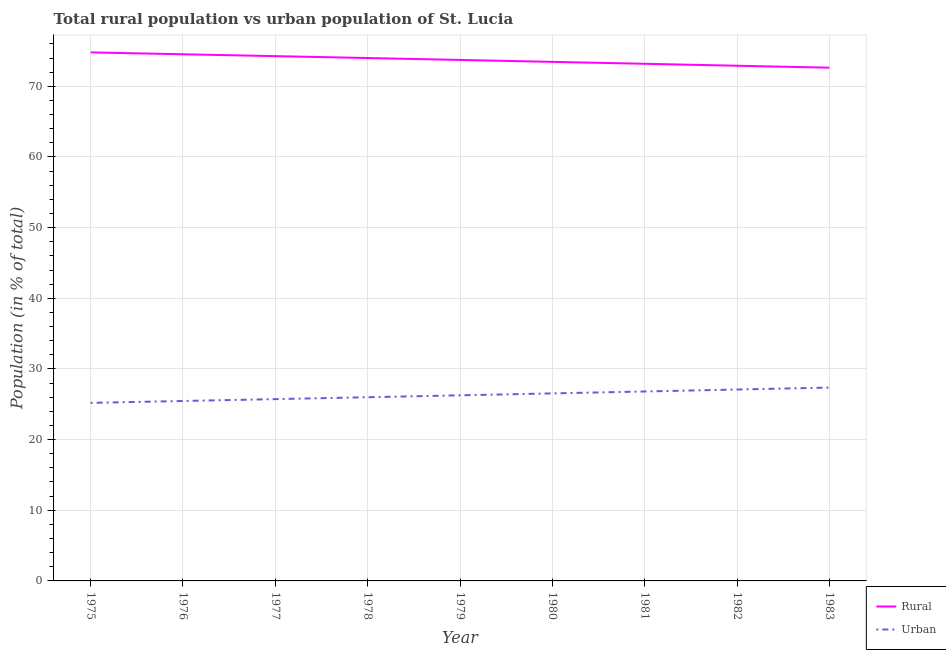What is the urban population in 1983?
Keep it short and to the point. 27.36. Across all years, what is the maximum rural population?
Your answer should be compact. 74.8. Across all years, what is the minimum rural population?
Offer a terse response. 72.64. In which year was the rural population maximum?
Your response must be concise. 1975. In which year was the urban population minimum?
Your answer should be compact. 1975. What is the total urban population in the graph?
Your answer should be very brief. 236.46. What is the difference between the urban population in 1978 and that in 1980?
Your answer should be very brief. -0.54. What is the difference between the rural population in 1980 and the urban population in 1981?
Provide a short and direct response. 46.65. What is the average urban population per year?
Keep it short and to the point. 26.27. In the year 1982, what is the difference between the urban population and rural population?
Make the answer very short. -45.83. What is the ratio of the urban population in 1980 to that in 1983?
Your answer should be very brief. 0.97. Is the urban population in 1978 less than that in 1981?
Give a very brief answer. Yes. What is the difference between the highest and the second highest rural population?
Keep it short and to the point. 0.27. What is the difference between the highest and the lowest rural population?
Ensure brevity in your answer.  2.16. In how many years, is the urban population greater than the average urban population taken over all years?
Provide a succinct answer. 4. Is the sum of the rural population in 1975 and 1980 greater than the maximum urban population across all years?
Provide a short and direct response. Yes. Is the urban population strictly less than the rural population over the years?
Provide a succinct answer. Yes. Are the values on the major ticks of Y-axis written in scientific E-notation?
Your answer should be compact. No. Does the graph contain any zero values?
Provide a short and direct response. No. What is the title of the graph?
Offer a very short reply. Total rural population vs urban population of St. Lucia. What is the label or title of the X-axis?
Provide a short and direct response. Year. What is the label or title of the Y-axis?
Give a very brief answer. Population (in % of total). What is the Population (in % of total) in Rural in 1975?
Keep it short and to the point. 74.8. What is the Population (in % of total) in Urban in 1975?
Make the answer very short. 25.2. What is the Population (in % of total) of Rural in 1976?
Offer a terse response. 74.53. What is the Population (in % of total) of Urban in 1976?
Give a very brief answer. 25.46. What is the Population (in % of total) of Rural in 1977?
Your answer should be very brief. 74.27. What is the Population (in % of total) in Urban in 1977?
Your answer should be very brief. 25.73. What is the Population (in % of total) of Rural in 1978?
Keep it short and to the point. 74. What is the Population (in % of total) in Urban in 1978?
Your answer should be compact. 26. What is the Population (in % of total) of Rural in 1979?
Keep it short and to the point. 73.73. What is the Population (in % of total) in Urban in 1979?
Offer a terse response. 26.27. What is the Population (in % of total) of Rural in 1980?
Offer a very short reply. 73.46. What is the Population (in % of total) in Urban in 1980?
Offer a terse response. 26.54. What is the Population (in % of total) of Rural in 1981?
Offer a terse response. 73.19. What is the Population (in % of total) of Urban in 1981?
Ensure brevity in your answer.  26.81. What is the Population (in % of total) in Rural in 1982?
Provide a succinct answer. 72.91. What is the Population (in % of total) of Urban in 1982?
Provide a short and direct response. 27.09. What is the Population (in % of total) of Rural in 1983?
Make the answer very short. 72.64. What is the Population (in % of total) in Urban in 1983?
Offer a very short reply. 27.36. Across all years, what is the maximum Population (in % of total) of Rural?
Make the answer very short. 74.8. Across all years, what is the maximum Population (in % of total) of Urban?
Make the answer very short. 27.36. Across all years, what is the minimum Population (in % of total) in Rural?
Your answer should be compact. 72.64. Across all years, what is the minimum Population (in % of total) in Urban?
Offer a terse response. 25.2. What is the total Population (in % of total) in Rural in the graph?
Make the answer very short. 663.54. What is the total Population (in % of total) of Urban in the graph?
Your answer should be very brief. 236.46. What is the difference between the Population (in % of total) of Rural in 1975 and that in 1976?
Keep it short and to the point. 0.27. What is the difference between the Population (in % of total) of Urban in 1975 and that in 1976?
Provide a short and direct response. -0.27. What is the difference between the Population (in % of total) in Rural in 1975 and that in 1977?
Make the answer very short. 0.53. What is the difference between the Population (in % of total) in Urban in 1975 and that in 1977?
Ensure brevity in your answer.  -0.53. What is the difference between the Population (in % of total) in Rural in 1975 and that in 1978?
Your response must be concise. 0.8. What is the difference between the Population (in % of total) of Urban in 1975 and that in 1978?
Keep it short and to the point. -0.8. What is the difference between the Population (in % of total) of Rural in 1975 and that in 1979?
Your answer should be very brief. 1.07. What is the difference between the Population (in % of total) in Urban in 1975 and that in 1979?
Keep it short and to the point. -1.07. What is the difference between the Population (in % of total) of Rural in 1975 and that in 1980?
Provide a succinct answer. 1.34. What is the difference between the Population (in % of total) of Urban in 1975 and that in 1980?
Ensure brevity in your answer.  -1.34. What is the difference between the Population (in % of total) of Rural in 1975 and that in 1981?
Offer a very short reply. 1.61. What is the difference between the Population (in % of total) in Urban in 1975 and that in 1981?
Keep it short and to the point. -1.61. What is the difference between the Population (in % of total) of Rural in 1975 and that in 1982?
Offer a terse response. 1.89. What is the difference between the Population (in % of total) of Urban in 1975 and that in 1982?
Offer a terse response. -1.89. What is the difference between the Population (in % of total) in Rural in 1975 and that in 1983?
Offer a very short reply. 2.16. What is the difference between the Population (in % of total) in Urban in 1975 and that in 1983?
Provide a short and direct response. -2.16. What is the difference between the Population (in % of total) in Rural in 1976 and that in 1977?
Ensure brevity in your answer.  0.27. What is the difference between the Population (in % of total) of Urban in 1976 and that in 1977?
Make the answer very short. -0.27. What is the difference between the Population (in % of total) of Rural in 1976 and that in 1978?
Your answer should be compact. 0.53. What is the difference between the Population (in % of total) in Urban in 1976 and that in 1978?
Your answer should be very brief. -0.53. What is the difference between the Population (in % of total) of Rural in 1976 and that in 1979?
Give a very brief answer. 0.8. What is the difference between the Population (in % of total) of Urban in 1976 and that in 1979?
Ensure brevity in your answer.  -0.8. What is the difference between the Population (in % of total) in Rural in 1976 and that in 1980?
Offer a terse response. 1.07. What is the difference between the Population (in % of total) of Urban in 1976 and that in 1980?
Provide a succinct answer. -1.07. What is the difference between the Population (in % of total) in Rural in 1976 and that in 1981?
Ensure brevity in your answer.  1.35. What is the difference between the Population (in % of total) of Urban in 1976 and that in 1981?
Provide a succinct answer. -1.35. What is the difference between the Population (in % of total) in Rural in 1976 and that in 1982?
Offer a terse response. 1.62. What is the difference between the Population (in % of total) in Urban in 1976 and that in 1982?
Your response must be concise. -1.62. What is the difference between the Population (in % of total) in Rural in 1976 and that in 1983?
Provide a short and direct response. 1.9. What is the difference between the Population (in % of total) of Urban in 1976 and that in 1983?
Keep it short and to the point. -1.9. What is the difference between the Population (in % of total) in Rural in 1977 and that in 1978?
Make the answer very short. 0.27. What is the difference between the Population (in % of total) of Urban in 1977 and that in 1978?
Keep it short and to the point. -0.27. What is the difference between the Population (in % of total) of Rural in 1977 and that in 1979?
Ensure brevity in your answer.  0.54. What is the difference between the Population (in % of total) of Urban in 1977 and that in 1979?
Provide a short and direct response. -0.54. What is the difference between the Population (in % of total) in Rural in 1977 and that in 1980?
Your answer should be very brief. 0.81. What is the difference between the Population (in % of total) in Urban in 1977 and that in 1980?
Your response must be concise. -0.81. What is the difference between the Population (in % of total) of Rural in 1977 and that in 1981?
Your answer should be compact. 1.08. What is the difference between the Population (in % of total) in Urban in 1977 and that in 1981?
Offer a terse response. -1.08. What is the difference between the Population (in % of total) of Rural in 1977 and that in 1982?
Offer a terse response. 1.36. What is the difference between the Population (in % of total) of Urban in 1977 and that in 1982?
Provide a succinct answer. -1.36. What is the difference between the Population (in % of total) in Rural in 1977 and that in 1983?
Your answer should be compact. 1.63. What is the difference between the Population (in % of total) in Urban in 1977 and that in 1983?
Your response must be concise. -1.63. What is the difference between the Population (in % of total) of Rural in 1978 and that in 1979?
Provide a short and direct response. 0.27. What is the difference between the Population (in % of total) in Urban in 1978 and that in 1979?
Provide a succinct answer. -0.27. What is the difference between the Population (in % of total) of Rural in 1978 and that in 1980?
Keep it short and to the point. 0.54. What is the difference between the Population (in % of total) of Urban in 1978 and that in 1980?
Your answer should be compact. -0.54. What is the difference between the Population (in % of total) of Rural in 1978 and that in 1981?
Offer a terse response. 0.81. What is the difference between the Population (in % of total) of Urban in 1978 and that in 1981?
Your response must be concise. -0.81. What is the difference between the Population (in % of total) of Rural in 1978 and that in 1982?
Ensure brevity in your answer.  1.09. What is the difference between the Population (in % of total) in Urban in 1978 and that in 1982?
Provide a short and direct response. -1.09. What is the difference between the Population (in % of total) of Rural in 1978 and that in 1983?
Your answer should be compact. 1.37. What is the difference between the Population (in % of total) in Urban in 1978 and that in 1983?
Your response must be concise. -1.37. What is the difference between the Population (in % of total) in Rural in 1979 and that in 1980?
Offer a very short reply. 0.27. What is the difference between the Population (in % of total) in Urban in 1979 and that in 1980?
Give a very brief answer. -0.27. What is the difference between the Population (in % of total) in Rural in 1979 and that in 1981?
Your answer should be very brief. 0.54. What is the difference between the Population (in % of total) of Urban in 1979 and that in 1981?
Your response must be concise. -0.54. What is the difference between the Population (in % of total) of Rural in 1979 and that in 1982?
Offer a terse response. 0.82. What is the difference between the Population (in % of total) of Urban in 1979 and that in 1982?
Your response must be concise. -0.82. What is the difference between the Population (in % of total) of Rural in 1979 and that in 1983?
Your response must be concise. 1.1. What is the difference between the Population (in % of total) of Urban in 1979 and that in 1983?
Give a very brief answer. -1.1. What is the difference between the Population (in % of total) of Rural in 1980 and that in 1981?
Give a very brief answer. 0.27. What is the difference between the Population (in % of total) of Urban in 1980 and that in 1981?
Give a very brief answer. -0.27. What is the difference between the Population (in % of total) in Rural in 1980 and that in 1982?
Your answer should be very brief. 0.55. What is the difference between the Population (in % of total) in Urban in 1980 and that in 1982?
Your answer should be compact. -0.55. What is the difference between the Population (in % of total) of Rural in 1980 and that in 1983?
Offer a very short reply. 0.82. What is the difference between the Population (in % of total) in Urban in 1980 and that in 1983?
Keep it short and to the point. -0.82. What is the difference between the Population (in % of total) of Rural in 1981 and that in 1982?
Provide a short and direct response. 0.28. What is the difference between the Population (in % of total) of Urban in 1981 and that in 1982?
Your answer should be compact. -0.28. What is the difference between the Population (in % of total) of Rural in 1981 and that in 1983?
Offer a terse response. 0.55. What is the difference between the Population (in % of total) in Urban in 1981 and that in 1983?
Offer a very short reply. -0.55. What is the difference between the Population (in % of total) of Rural in 1982 and that in 1983?
Your answer should be compact. 0.28. What is the difference between the Population (in % of total) in Urban in 1982 and that in 1983?
Your answer should be compact. -0.28. What is the difference between the Population (in % of total) of Rural in 1975 and the Population (in % of total) of Urban in 1976?
Give a very brief answer. 49.34. What is the difference between the Population (in % of total) in Rural in 1975 and the Population (in % of total) in Urban in 1977?
Offer a very short reply. 49.07. What is the difference between the Population (in % of total) of Rural in 1975 and the Population (in % of total) of Urban in 1978?
Offer a terse response. 48.8. What is the difference between the Population (in % of total) in Rural in 1975 and the Population (in % of total) in Urban in 1979?
Keep it short and to the point. 48.53. What is the difference between the Population (in % of total) of Rural in 1975 and the Population (in % of total) of Urban in 1980?
Provide a succinct answer. 48.26. What is the difference between the Population (in % of total) in Rural in 1975 and the Population (in % of total) in Urban in 1981?
Offer a terse response. 47.99. What is the difference between the Population (in % of total) in Rural in 1975 and the Population (in % of total) in Urban in 1982?
Provide a short and direct response. 47.71. What is the difference between the Population (in % of total) in Rural in 1975 and the Population (in % of total) in Urban in 1983?
Your answer should be very brief. 47.44. What is the difference between the Population (in % of total) of Rural in 1976 and the Population (in % of total) of Urban in 1977?
Provide a short and direct response. 48.8. What is the difference between the Population (in % of total) of Rural in 1976 and the Population (in % of total) of Urban in 1978?
Your answer should be compact. 48.54. What is the difference between the Population (in % of total) in Rural in 1976 and the Population (in % of total) in Urban in 1979?
Provide a short and direct response. 48.27. What is the difference between the Population (in % of total) of Rural in 1976 and the Population (in % of total) of Urban in 1980?
Your answer should be compact. 47.99. What is the difference between the Population (in % of total) in Rural in 1976 and the Population (in % of total) in Urban in 1981?
Offer a very short reply. 47.72. What is the difference between the Population (in % of total) of Rural in 1976 and the Population (in % of total) of Urban in 1982?
Keep it short and to the point. 47.45. What is the difference between the Population (in % of total) of Rural in 1976 and the Population (in % of total) of Urban in 1983?
Ensure brevity in your answer.  47.17. What is the difference between the Population (in % of total) of Rural in 1977 and the Population (in % of total) of Urban in 1978?
Give a very brief answer. 48.27. What is the difference between the Population (in % of total) of Rural in 1977 and the Population (in % of total) of Urban in 1979?
Your answer should be very brief. 48. What is the difference between the Population (in % of total) of Rural in 1977 and the Population (in % of total) of Urban in 1980?
Ensure brevity in your answer.  47.73. What is the difference between the Population (in % of total) in Rural in 1977 and the Population (in % of total) in Urban in 1981?
Keep it short and to the point. 47.46. What is the difference between the Population (in % of total) in Rural in 1977 and the Population (in % of total) in Urban in 1982?
Make the answer very short. 47.18. What is the difference between the Population (in % of total) in Rural in 1977 and the Population (in % of total) in Urban in 1983?
Give a very brief answer. 46.91. What is the difference between the Population (in % of total) in Rural in 1978 and the Population (in % of total) in Urban in 1979?
Your response must be concise. 47.73. What is the difference between the Population (in % of total) of Rural in 1978 and the Population (in % of total) of Urban in 1980?
Your answer should be compact. 47.46. What is the difference between the Population (in % of total) of Rural in 1978 and the Population (in % of total) of Urban in 1981?
Make the answer very short. 47.19. What is the difference between the Population (in % of total) in Rural in 1978 and the Population (in % of total) in Urban in 1982?
Provide a succinct answer. 46.91. What is the difference between the Population (in % of total) of Rural in 1978 and the Population (in % of total) of Urban in 1983?
Keep it short and to the point. 46.64. What is the difference between the Population (in % of total) of Rural in 1979 and the Population (in % of total) of Urban in 1980?
Make the answer very short. 47.19. What is the difference between the Population (in % of total) in Rural in 1979 and the Population (in % of total) in Urban in 1981?
Offer a terse response. 46.92. What is the difference between the Population (in % of total) in Rural in 1979 and the Population (in % of total) in Urban in 1982?
Ensure brevity in your answer.  46.65. What is the difference between the Population (in % of total) in Rural in 1979 and the Population (in % of total) in Urban in 1983?
Make the answer very short. 46.37. What is the difference between the Population (in % of total) of Rural in 1980 and the Population (in % of total) of Urban in 1981?
Give a very brief answer. 46.65. What is the difference between the Population (in % of total) in Rural in 1980 and the Population (in % of total) in Urban in 1982?
Ensure brevity in your answer.  46.37. What is the difference between the Population (in % of total) of Rural in 1980 and the Population (in % of total) of Urban in 1983?
Offer a very short reply. 46.1. What is the difference between the Population (in % of total) of Rural in 1981 and the Population (in % of total) of Urban in 1982?
Provide a short and direct response. 46.1. What is the difference between the Population (in % of total) in Rural in 1981 and the Population (in % of total) in Urban in 1983?
Offer a terse response. 45.82. What is the difference between the Population (in % of total) in Rural in 1982 and the Population (in % of total) in Urban in 1983?
Your answer should be very brief. 45.55. What is the average Population (in % of total) in Rural per year?
Your answer should be very brief. 73.73. What is the average Population (in % of total) in Urban per year?
Make the answer very short. 26.27. In the year 1975, what is the difference between the Population (in % of total) of Rural and Population (in % of total) of Urban?
Ensure brevity in your answer.  49.6. In the year 1976, what is the difference between the Population (in % of total) in Rural and Population (in % of total) in Urban?
Make the answer very short. 49.07. In the year 1977, what is the difference between the Population (in % of total) in Rural and Population (in % of total) in Urban?
Provide a succinct answer. 48.54. In the year 1978, what is the difference between the Population (in % of total) of Rural and Population (in % of total) of Urban?
Give a very brief answer. 48. In the year 1979, what is the difference between the Population (in % of total) in Rural and Population (in % of total) in Urban?
Your answer should be very brief. 47.46. In the year 1980, what is the difference between the Population (in % of total) in Rural and Population (in % of total) in Urban?
Your answer should be compact. 46.92. In the year 1981, what is the difference between the Population (in % of total) of Rural and Population (in % of total) of Urban?
Your answer should be compact. 46.38. In the year 1982, what is the difference between the Population (in % of total) in Rural and Population (in % of total) in Urban?
Provide a succinct answer. 45.83. In the year 1983, what is the difference between the Population (in % of total) of Rural and Population (in % of total) of Urban?
Your response must be concise. 45.27. What is the ratio of the Population (in % of total) of Urban in 1975 to that in 1976?
Give a very brief answer. 0.99. What is the ratio of the Population (in % of total) of Rural in 1975 to that in 1977?
Give a very brief answer. 1.01. What is the ratio of the Population (in % of total) in Urban in 1975 to that in 1977?
Keep it short and to the point. 0.98. What is the ratio of the Population (in % of total) in Rural in 1975 to that in 1978?
Make the answer very short. 1.01. What is the ratio of the Population (in % of total) of Urban in 1975 to that in 1978?
Keep it short and to the point. 0.97. What is the ratio of the Population (in % of total) of Rural in 1975 to that in 1979?
Make the answer very short. 1.01. What is the ratio of the Population (in % of total) of Urban in 1975 to that in 1979?
Give a very brief answer. 0.96. What is the ratio of the Population (in % of total) of Rural in 1975 to that in 1980?
Keep it short and to the point. 1.02. What is the ratio of the Population (in % of total) in Urban in 1975 to that in 1980?
Give a very brief answer. 0.95. What is the ratio of the Population (in % of total) in Rural in 1975 to that in 1981?
Keep it short and to the point. 1.02. What is the ratio of the Population (in % of total) of Urban in 1975 to that in 1981?
Make the answer very short. 0.94. What is the ratio of the Population (in % of total) of Rural in 1975 to that in 1982?
Offer a very short reply. 1.03. What is the ratio of the Population (in % of total) in Urban in 1975 to that in 1982?
Keep it short and to the point. 0.93. What is the ratio of the Population (in % of total) of Rural in 1975 to that in 1983?
Your response must be concise. 1.03. What is the ratio of the Population (in % of total) in Urban in 1975 to that in 1983?
Give a very brief answer. 0.92. What is the ratio of the Population (in % of total) in Rural in 1976 to that in 1978?
Provide a succinct answer. 1.01. What is the ratio of the Population (in % of total) in Urban in 1976 to that in 1978?
Your response must be concise. 0.98. What is the ratio of the Population (in % of total) in Rural in 1976 to that in 1979?
Give a very brief answer. 1.01. What is the ratio of the Population (in % of total) in Urban in 1976 to that in 1979?
Your response must be concise. 0.97. What is the ratio of the Population (in % of total) of Rural in 1976 to that in 1980?
Your response must be concise. 1.01. What is the ratio of the Population (in % of total) in Urban in 1976 to that in 1980?
Give a very brief answer. 0.96. What is the ratio of the Population (in % of total) in Rural in 1976 to that in 1981?
Make the answer very short. 1.02. What is the ratio of the Population (in % of total) in Urban in 1976 to that in 1981?
Keep it short and to the point. 0.95. What is the ratio of the Population (in % of total) of Rural in 1976 to that in 1982?
Give a very brief answer. 1.02. What is the ratio of the Population (in % of total) in Urban in 1976 to that in 1982?
Make the answer very short. 0.94. What is the ratio of the Population (in % of total) of Rural in 1976 to that in 1983?
Ensure brevity in your answer.  1.03. What is the ratio of the Population (in % of total) in Urban in 1976 to that in 1983?
Give a very brief answer. 0.93. What is the ratio of the Population (in % of total) in Rural in 1977 to that in 1978?
Make the answer very short. 1. What is the ratio of the Population (in % of total) of Urban in 1977 to that in 1978?
Your answer should be compact. 0.99. What is the ratio of the Population (in % of total) in Rural in 1977 to that in 1979?
Offer a very short reply. 1.01. What is the ratio of the Population (in % of total) of Urban in 1977 to that in 1979?
Ensure brevity in your answer.  0.98. What is the ratio of the Population (in % of total) of Rural in 1977 to that in 1980?
Offer a very short reply. 1.01. What is the ratio of the Population (in % of total) of Urban in 1977 to that in 1980?
Your answer should be very brief. 0.97. What is the ratio of the Population (in % of total) of Rural in 1977 to that in 1981?
Your answer should be very brief. 1.01. What is the ratio of the Population (in % of total) of Urban in 1977 to that in 1981?
Provide a short and direct response. 0.96. What is the ratio of the Population (in % of total) in Rural in 1977 to that in 1982?
Make the answer very short. 1.02. What is the ratio of the Population (in % of total) of Urban in 1977 to that in 1982?
Your answer should be compact. 0.95. What is the ratio of the Population (in % of total) of Rural in 1977 to that in 1983?
Provide a short and direct response. 1.02. What is the ratio of the Population (in % of total) in Urban in 1977 to that in 1983?
Offer a terse response. 0.94. What is the ratio of the Population (in % of total) in Rural in 1978 to that in 1979?
Make the answer very short. 1. What is the ratio of the Population (in % of total) of Rural in 1978 to that in 1980?
Give a very brief answer. 1.01. What is the ratio of the Population (in % of total) in Urban in 1978 to that in 1980?
Make the answer very short. 0.98. What is the ratio of the Population (in % of total) in Rural in 1978 to that in 1981?
Offer a terse response. 1.01. What is the ratio of the Population (in % of total) of Urban in 1978 to that in 1981?
Make the answer very short. 0.97. What is the ratio of the Population (in % of total) of Rural in 1978 to that in 1982?
Make the answer very short. 1.01. What is the ratio of the Population (in % of total) of Urban in 1978 to that in 1982?
Offer a terse response. 0.96. What is the ratio of the Population (in % of total) in Rural in 1978 to that in 1983?
Ensure brevity in your answer.  1.02. What is the ratio of the Population (in % of total) in Urban in 1978 to that in 1983?
Provide a short and direct response. 0.95. What is the ratio of the Population (in % of total) in Rural in 1979 to that in 1980?
Your answer should be compact. 1. What is the ratio of the Population (in % of total) of Rural in 1979 to that in 1981?
Provide a short and direct response. 1.01. What is the ratio of the Population (in % of total) in Urban in 1979 to that in 1981?
Keep it short and to the point. 0.98. What is the ratio of the Population (in % of total) in Rural in 1979 to that in 1982?
Your answer should be compact. 1.01. What is the ratio of the Population (in % of total) of Urban in 1979 to that in 1982?
Your answer should be compact. 0.97. What is the ratio of the Population (in % of total) in Rural in 1979 to that in 1983?
Provide a succinct answer. 1.02. What is the ratio of the Population (in % of total) of Urban in 1979 to that in 1983?
Make the answer very short. 0.96. What is the ratio of the Population (in % of total) in Rural in 1980 to that in 1981?
Provide a succinct answer. 1. What is the ratio of the Population (in % of total) in Rural in 1980 to that in 1982?
Offer a very short reply. 1.01. What is the ratio of the Population (in % of total) in Urban in 1980 to that in 1982?
Your answer should be very brief. 0.98. What is the ratio of the Population (in % of total) of Rural in 1980 to that in 1983?
Offer a very short reply. 1.01. What is the ratio of the Population (in % of total) of Urban in 1980 to that in 1983?
Offer a terse response. 0.97. What is the ratio of the Population (in % of total) of Rural in 1981 to that in 1982?
Offer a very short reply. 1. What is the ratio of the Population (in % of total) in Rural in 1981 to that in 1983?
Provide a short and direct response. 1.01. What is the ratio of the Population (in % of total) in Urban in 1981 to that in 1983?
Make the answer very short. 0.98. What is the ratio of the Population (in % of total) in Rural in 1982 to that in 1983?
Your answer should be very brief. 1. What is the difference between the highest and the second highest Population (in % of total) of Rural?
Your answer should be compact. 0.27. What is the difference between the highest and the second highest Population (in % of total) in Urban?
Your answer should be compact. 0.28. What is the difference between the highest and the lowest Population (in % of total) in Rural?
Make the answer very short. 2.16. What is the difference between the highest and the lowest Population (in % of total) of Urban?
Offer a very short reply. 2.16. 